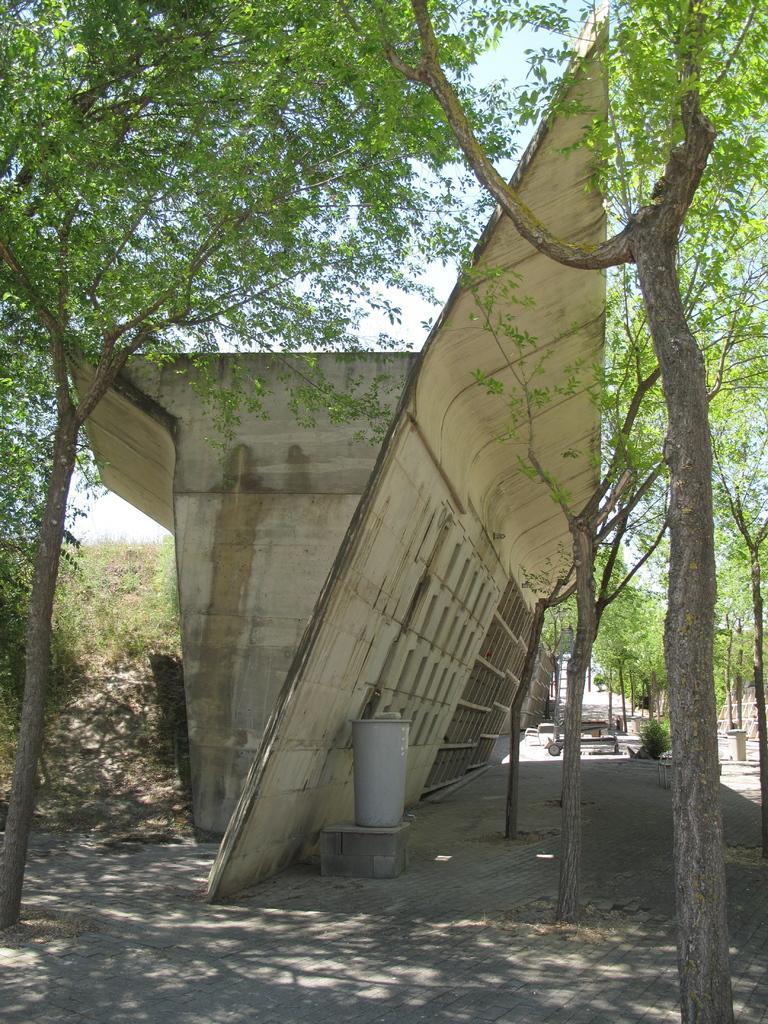Please provide a concise description of this image. In this picture I can see construction bridge. At the bottom there is a dustbins. In the background I can see the trees, plants and grass. At the top I can see the sky and clouds. 